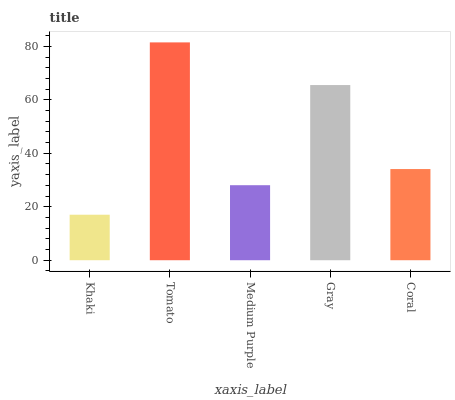Is Medium Purple the minimum?
Answer yes or no. No. Is Medium Purple the maximum?
Answer yes or no. No. Is Tomato greater than Medium Purple?
Answer yes or no. Yes. Is Medium Purple less than Tomato?
Answer yes or no. Yes. Is Medium Purple greater than Tomato?
Answer yes or no. No. Is Tomato less than Medium Purple?
Answer yes or no. No. Is Coral the high median?
Answer yes or no. Yes. Is Coral the low median?
Answer yes or no. Yes. Is Gray the high median?
Answer yes or no. No. Is Gray the low median?
Answer yes or no. No. 